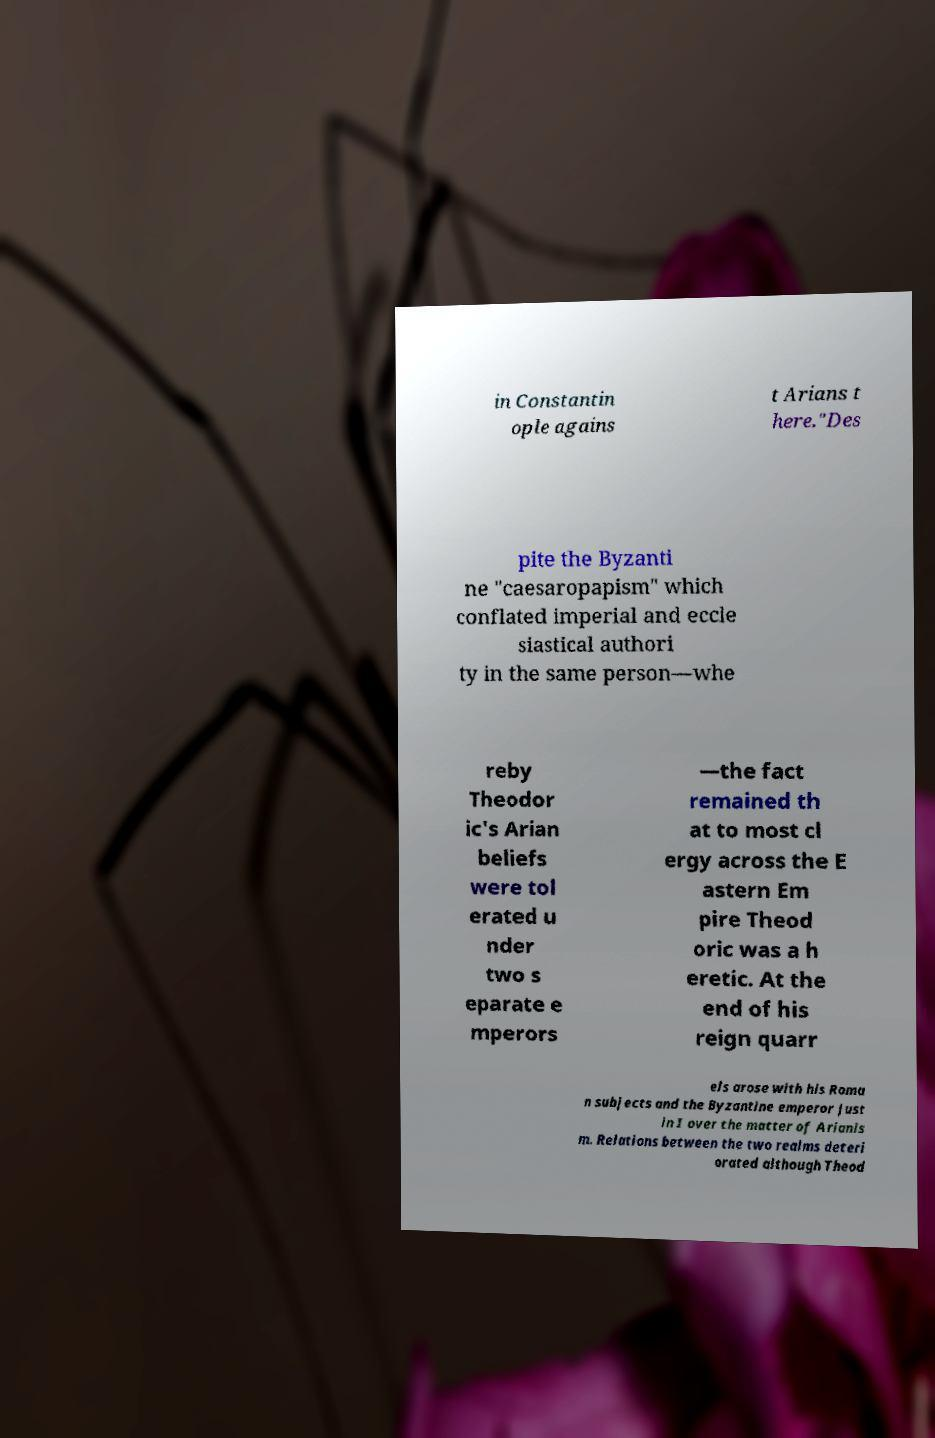Could you extract and type out the text from this image? in Constantin ople agains t Arians t here."Des pite the Byzanti ne "caesaropapism" which conflated imperial and eccle siastical authori ty in the same person—whe reby Theodor ic's Arian beliefs were tol erated u nder two s eparate e mperors —the fact remained th at to most cl ergy across the E astern Em pire Theod oric was a h eretic. At the end of his reign quarr els arose with his Roma n subjects and the Byzantine emperor Just in I over the matter of Arianis m. Relations between the two realms deteri orated although Theod 